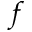<formula> <loc_0><loc_0><loc_500><loc_500>f</formula> 